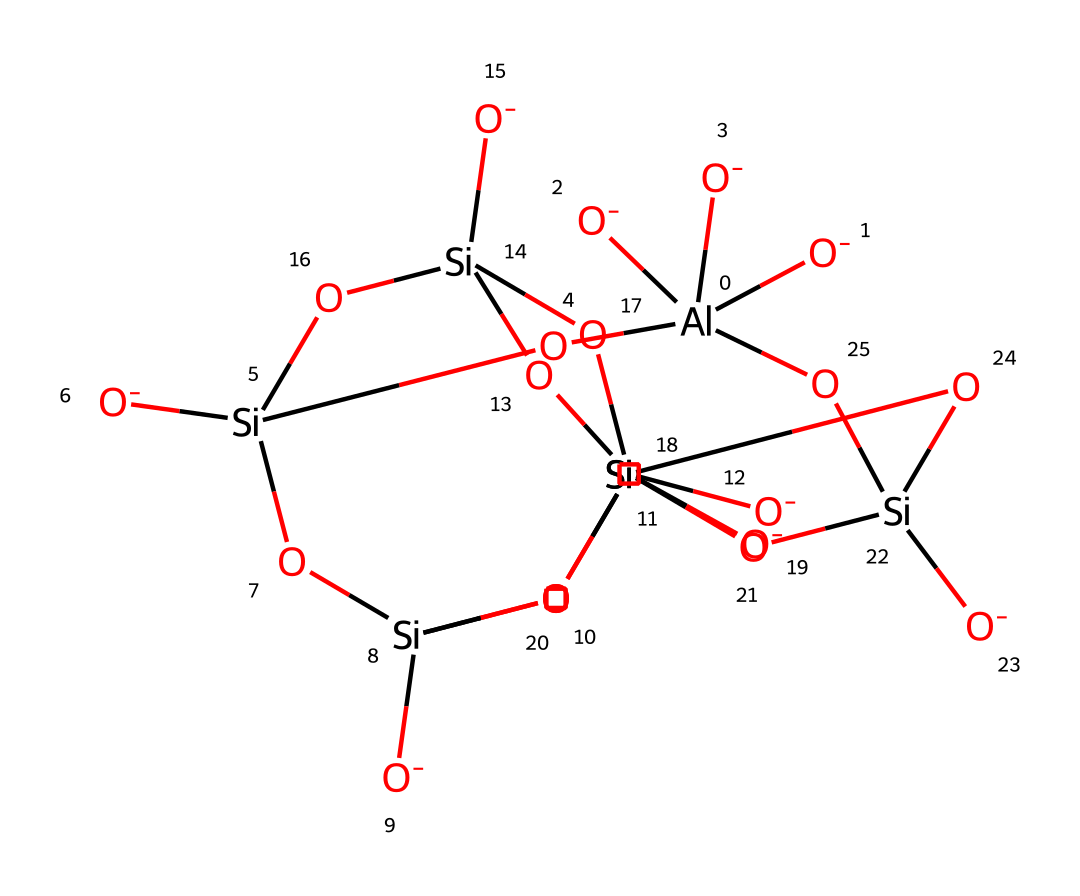What is the primary metal present in this molecule? The chemical structure showcases aluminum (indicated by the symbol [Al]), which is a metal that often plays a critical role in the composition of clay minerals.
Answer: aluminum How many silicon atoms are present in this structure? By analyzing the chemical, we can see that there are four distinct [Si] symbols, representing four silicon atoms within the structure.
Answer: four What type of bonding is predominantly indicated in clay minerals like this? The presence of multiple oxygen atoms bonded to silicon and aluminum suggests a network of covalent bonds, which is characteristic of the strong bonds found in silicate minerals like clay.
Answer: covalent What is the overall charge of this chemical structure? Each aluminum atom is shown to have a -3 charge due to the three [O-] symbols, while the silicon atoms are neutral in this representation. Thus, the overall charge can be determined as negative.
Answer: negative Which type of materials can be formed using this chemical structure? This molecular composition is associated with ceramic materials; since it consists of clay minerals, it can be used to make decorative tiles that are durable and aesthetically appealing.
Answer: ceramic materials 